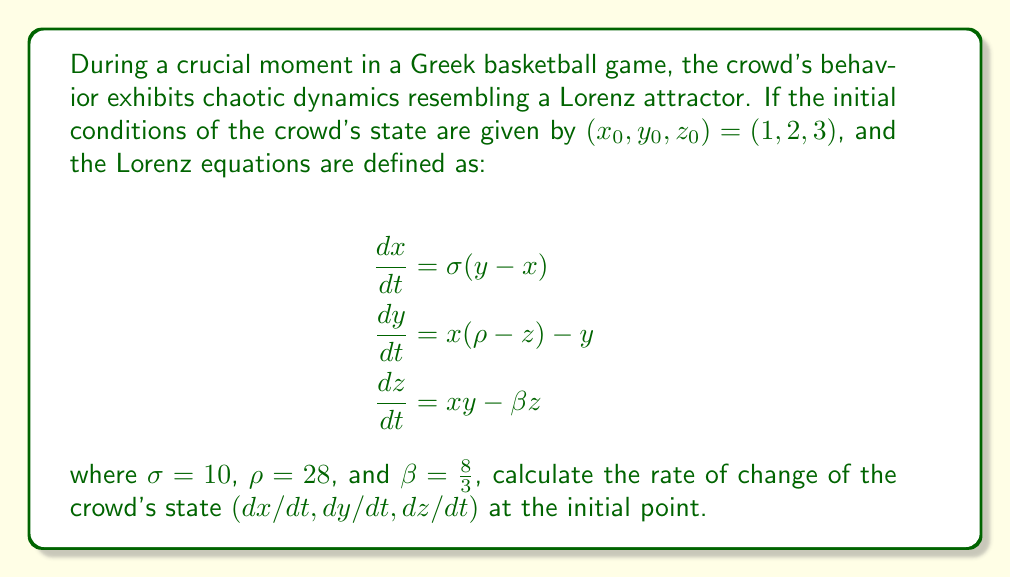Show me your answer to this math problem. To solve this problem, we need to follow these steps:

1. We have the initial conditions: $(x_0, y_0, z_0) = (1, 2, 3)$

2. We're given the Lorenz equations and the parameter values:
   $\sigma = 10$, $\rho = 28$, and $\beta = \frac{8}{3}$

3. Let's calculate $dx/dt$:
   $$\frac{dx}{dt} = \sigma(y - x) = 10(2 - 1) = 10$$

4. Now, let's calculate $dy/dt$:
   $$\frac{dy}{dt} = x(\rho - z) - y = 1(28 - 3) - 2 = 25 - 2 = 23$$

5. Finally, let's calculate $dz/dt$:
   $$\frac{dz}{dt} = xy - \beta z = 1 \cdot 2 - \frac{8}{3} \cdot 3 = 2 - 8 = -6$$

6. Combining these results, we get the rate of change of the crowd's state at the initial point:
   $(dx/dt, dy/dt, dz/dt) = (10, 23, -6)$

This result represents the instantaneous rate of change in the crowd's behavior at the given moment, providing insight into how the chaotic dynamics are evolving.
Answer: $(10, 23, -6)$ 